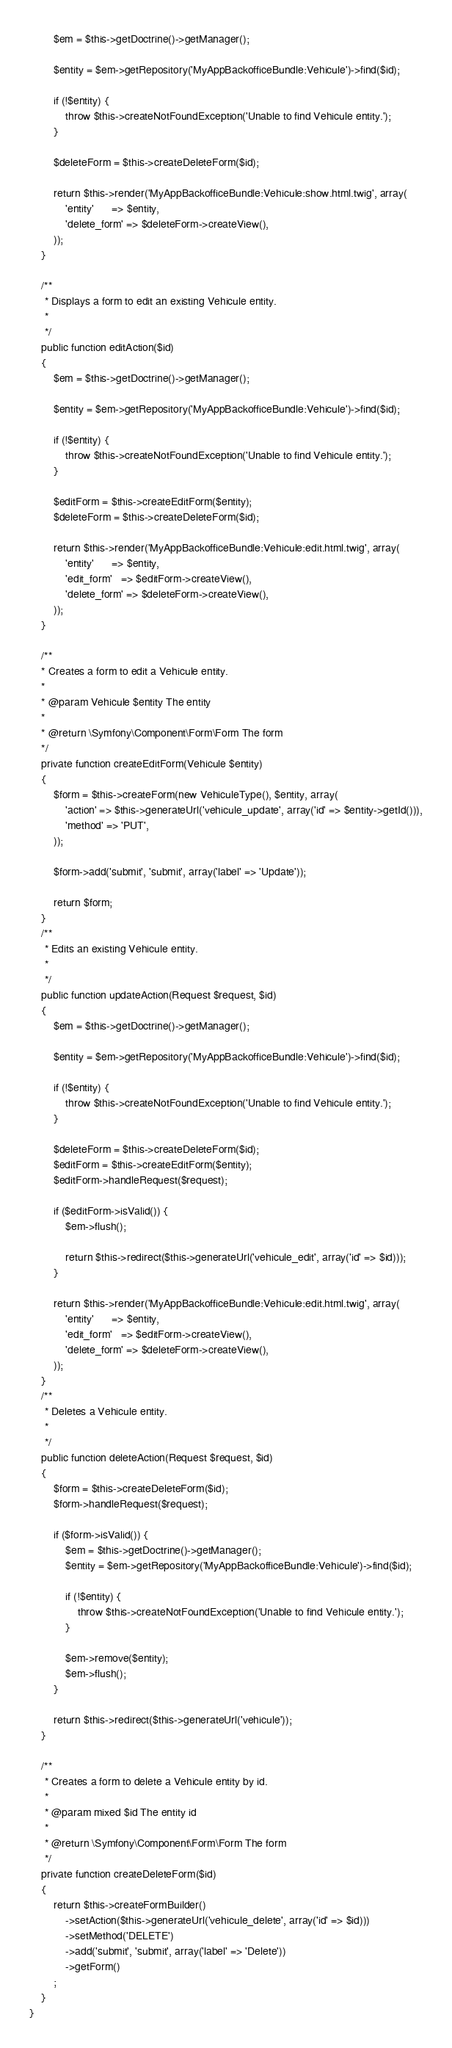<code> <loc_0><loc_0><loc_500><loc_500><_PHP_>        $em = $this->getDoctrine()->getManager();

        $entity = $em->getRepository('MyAppBackofficeBundle:Vehicule')->find($id);

        if (!$entity) {
            throw $this->createNotFoundException('Unable to find Vehicule entity.');
        }

        $deleteForm = $this->createDeleteForm($id);

        return $this->render('MyAppBackofficeBundle:Vehicule:show.html.twig', array(
            'entity'      => $entity,
            'delete_form' => $deleteForm->createView(),
        ));
    }

    /**
     * Displays a form to edit an existing Vehicule entity.
     *
     */
    public function editAction($id)
    {
        $em = $this->getDoctrine()->getManager();

        $entity = $em->getRepository('MyAppBackofficeBundle:Vehicule')->find($id);

        if (!$entity) {
            throw $this->createNotFoundException('Unable to find Vehicule entity.');
        }

        $editForm = $this->createEditForm($entity);
        $deleteForm = $this->createDeleteForm($id);

        return $this->render('MyAppBackofficeBundle:Vehicule:edit.html.twig', array(
            'entity'      => $entity,
            'edit_form'   => $editForm->createView(),
            'delete_form' => $deleteForm->createView(),
        ));
    }

    /**
    * Creates a form to edit a Vehicule entity.
    *
    * @param Vehicule $entity The entity
    *
    * @return \Symfony\Component\Form\Form The form
    */
    private function createEditForm(Vehicule $entity)
    {
        $form = $this->createForm(new VehiculeType(), $entity, array(
            'action' => $this->generateUrl('vehicule_update', array('id' => $entity->getId())),
            'method' => 'PUT',
        ));

        $form->add('submit', 'submit', array('label' => 'Update'));

        return $form;
    }
    /**
     * Edits an existing Vehicule entity.
     *
     */
    public function updateAction(Request $request, $id)
    {
        $em = $this->getDoctrine()->getManager();

        $entity = $em->getRepository('MyAppBackofficeBundle:Vehicule')->find($id);

        if (!$entity) {
            throw $this->createNotFoundException('Unable to find Vehicule entity.');
        }

        $deleteForm = $this->createDeleteForm($id);
        $editForm = $this->createEditForm($entity);
        $editForm->handleRequest($request);

        if ($editForm->isValid()) {
            $em->flush();

            return $this->redirect($this->generateUrl('vehicule_edit', array('id' => $id)));
        }

        return $this->render('MyAppBackofficeBundle:Vehicule:edit.html.twig', array(
            'entity'      => $entity,
            'edit_form'   => $editForm->createView(),
            'delete_form' => $deleteForm->createView(),
        ));
    }
    /**
     * Deletes a Vehicule entity.
     *
     */
    public function deleteAction(Request $request, $id)
    {
        $form = $this->createDeleteForm($id);
        $form->handleRequest($request);

        if ($form->isValid()) {
            $em = $this->getDoctrine()->getManager();
            $entity = $em->getRepository('MyAppBackofficeBundle:Vehicule')->find($id);

            if (!$entity) {
                throw $this->createNotFoundException('Unable to find Vehicule entity.');
            }

            $em->remove($entity);
            $em->flush();
        }

        return $this->redirect($this->generateUrl('vehicule'));
    }

    /**
     * Creates a form to delete a Vehicule entity by id.
     *
     * @param mixed $id The entity id
     *
     * @return \Symfony\Component\Form\Form The form
     */
    private function createDeleteForm($id)
    {
        return $this->createFormBuilder()
            ->setAction($this->generateUrl('vehicule_delete', array('id' => $id)))
            ->setMethod('DELETE')
            ->add('submit', 'submit', array('label' => 'Delete'))
            ->getForm()
        ;
    }
}
</code> 